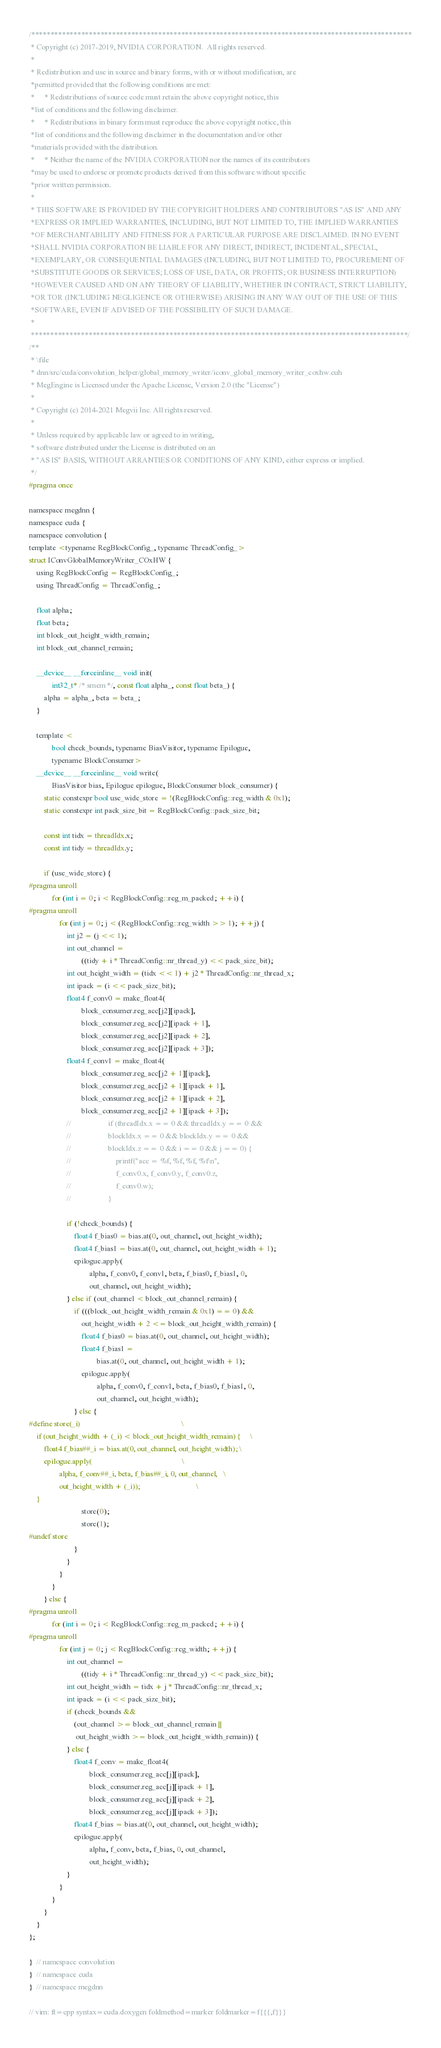<code> <loc_0><loc_0><loc_500><loc_500><_Cuda_>/***************************************************************************************************
 * Copyright (c) 2017-2019, NVIDIA CORPORATION.  All rights reserved.
 *
 * Redistribution and use in source and binary forms, with or without modification, are
 *permitted provided that the following conditions are met:
 *     * Redistributions of source code must retain the above copyright notice, this
 *list of conditions and the following disclaimer.
 *     * Redistributions in binary form must reproduce the above copyright notice, this
 *list of conditions and the following disclaimer in the documentation and/or other
 *materials provided with the distribution.
 *     * Neither the name of the NVIDIA CORPORATION nor the names of its contributors
 *may be used to endorse or promote products derived from this software without specific
 *prior written permission.
 *
 * THIS SOFTWARE IS PROVIDED BY THE COPYRIGHT HOLDERS AND CONTRIBUTORS "AS IS" AND ANY
 *EXPRESS OR IMPLIED WARRANTIES, INCLUDING, BUT NOT LIMITED TO, THE IMPLIED WARRANTIES
 *OF MERCHANTABILITY AND FITNESS FOR A PARTICULAR PURPOSE ARE DISCLAIMED. IN NO EVENT
 *SHALL NVIDIA CORPORATION BE LIABLE FOR ANY DIRECT, INDIRECT, INCIDENTAL, SPECIAL,
 *EXEMPLARY, OR CONSEQUENTIAL DAMAGES (INCLUDING, BUT NOT LIMITED TO, PROCUREMENT OF
 *SUBSTITUTE GOODS OR SERVICES; LOSS OF USE, DATA, OR PROFITS; OR BUSINESS INTERRUPTION)
 *HOWEVER CAUSED AND ON ANY THEORY OF LIABILITY, WHETHER IN CONTRACT, STRICT LIABILITY,
 *OR TOR (INCLUDING NEGLIGENCE OR OTHERWISE) ARISING IN ANY WAY OUT OF THE USE OF THIS
 *SOFTWARE, EVEN IF ADVISED OF THE POSSIBILITY OF SUCH DAMAGE.
 *
 **************************************************************************************************/
/**
 * \file
 * dnn/src/cuda/convolution_helper/global_memory_writer/iconv_global_memory_writer_coxhw.cuh
 * MegEngine is Licensed under the Apache License, Version 2.0 (the "License")
 *
 * Copyright (c) 2014-2021 Megvii Inc. All rights reserved.
 *
 * Unless required by applicable law or agreed to in writing,
 * software distributed under the License is distributed on an
 * "AS IS" BASIS, WITHOUT ARRANTIES OR CONDITIONS OF ANY KIND, either express or implied.
 */
#pragma once

namespace megdnn {
namespace cuda {
namespace convolution {
template <typename RegBlockConfig_, typename ThreadConfig_>
struct IConvGlobalMemoryWriter_COxHW {
    using RegBlockConfig = RegBlockConfig_;
    using ThreadConfig = ThreadConfig_;

    float alpha;
    float beta;
    int block_out_height_width_remain;
    int block_out_channel_remain;

    __device__ __forceinline__ void init(
            int32_t* /* smem */, const float alpha_, const float beta_) {
        alpha = alpha_, beta = beta_;
    }

    template <
            bool check_bounds, typename BiasVisitor, typename Epilogue,
            typename BlockConsumer>
    __device__ __forceinline__ void write(
            BiasVisitor bias, Epilogue epilogue, BlockConsumer block_consumer) {
        static constexpr bool use_wide_store = !(RegBlockConfig::reg_width & 0x1);
        static constexpr int pack_size_bit = RegBlockConfig::pack_size_bit;

        const int tidx = threadIdx.x;
        const int tidy = threadIdx.y;

        if (use_wide_store) {
#pragma unroll
            for (int i = 0; i < RegBlockConfig::reg_m_packed; ++i) {
#pragma unroll
                for (int j = 0; j < (RegBlockConfig::reg_width >> 1); ++j) {
                    int j2 = (j << 1);
                    int out_channel =
                            ((tidy + i * ThreadConfig::nr_thread_y) << pack_size_bit);
                    int out_height_width = (tidx << 1) + j2 * ThreadConfig::nr_thread_x;
                    int ipack = (i << pack_size_bit);
                    float4 f_conv0 = make_float4(
                            block_consumer.reg_acc[j2][ipack],
                            block_consumer.reg_acc[j2][ipack + 1],
                            block_consumer.reg_acc[j2][ipack + 2],
                            block_consumer.reg_acc[j2][ipack + 3]);
                    float4 f_conv1 = make_float4(
                            block_consumer.reg_acc[j2 + 1][ipack],
                            block_consumer.reg_acc[j2 + 1][ipack + 1],
                            block_consumer.reg_acc[j2 + 1][ipack + 2],
                            block_consumer.reg_acc[j2 + 1][ipack + 3]);
                    //                    if (threadIdx.x == 0 && threadIdx.y == 0 &&
                    //                    blockIdx.x == 0 && blockIdx.y == 0 &&
                    //                    blockIdx.z == 0 && i == 0 && j == 0) {
                    //                        printf("acc = %f, %f, %f, %f\n",
                    //                        f_conv0.x, f_conv0.y, f_conv0.z,
                    //                        f_conv0.w);
                    //                    }

                    if (!check_bounds) {
                        float4 f_bias0 = bias.at(0, out_channel, out_height_width);
                        float4 f_bias1 = bias.at(0, out_channel, out_height_width + 1);
                        epilogue.apply(
                                alpha, f_conv0, f_conv1, beta, f_bias0, f_bias1, 0,
                                out_channel, out_height_width);
                    } else if (out_channel < block_out_channel_remain) {
                        if (((block_out_height_width_remain & 0x1) == 0) &&
                            out_height_width + 2 <= block_out_height_width_remain) {
                            float4 f_bias0 = bias.at(0, out_channel, out_height_width);
                            float4 f_bias1 =
                                    bias.at(0, out_channel, out_height_width + 1);
                            epilogue.apply(
                                    alpha, f_conv0, f_conv1, beta, f_bias0, f_bias1, 0,
                                    out_channel, out_height_width);
                        } else {
#define store(_i)                                                      \
    if (out_height_width + (_i) < block_out_height_width_remain) {     \
        float4 f_bias##_i = bias.at(0, out_channel, out_height_width); \
        epilogue.apply(                                                \
                alpha, f_conv##_i, beta, f_bias##_i, 0, out_channel,   \
                out_height_width + (_i));                              \
    }
                            store(0);
                            store(1);
#undef store
                        }
                    }
                }
            }
        } else {
#pragma unroll
            for (int i = 0; i < RegBlockConfig::reg_m_packed; ++i) {
#pragma unroll
                for (int j = 0; j < RegBlockConfig::reg_width; ++j) {
                    int out_channel =
                            ((tidy + i * ThreadConfig::nr_thread_y) << pack_size_bit);
                    int out_height_width = tidx + j * ThreadConfig::nr_thread_x;
                    int ipack = (i << pack_size_bit);
                    if (check_bounds &&
                        (out_channel >= block_out_channel_remain ||
                         out_height_width >= block_out_height_width_remain)) {
                    } else {
                        float4 f_conv = make_float4(
                                block_consumer.reg_acc[j][ipack],
                                block_consumer.reg_acc[j][ipack + 1],
                                block_consumer.reg_acc[j][ipack + 2],
                                block_consumer.reg_acc[j][ipack + 3]);
                        float4 f_bias = bias.at(0, out_channel, out_height_width);
                        epilogue.apply(
                                alpha, f_conv, beta, f_bias, 0, out_channel,
                                out_height_width);
                    }
                }
            }
        }
    }
};

}  // namespace convolution
}  // namespace cuda
}  // namespace megdnn

// vim: ft=cpp syntax=cuda.doxygen foldmethod=marker foldmarker=f{{{,f}}}
</code> 